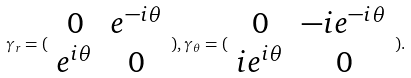<formula> <loc_0><loc_0><loc_500><loc_500>\gamma _ { r } = ( \begin{array} { c c } 0 & e ^ { - i \theta } \\ e ^ { i \theta } & 0 \end{array} ) , \gamma _ { \theta } = ( \begin{array} { c c } 0 & - i e ^ { - i \theta } \\ i e ^ { i \theta } & 0 \end{array} ) .</formula> 